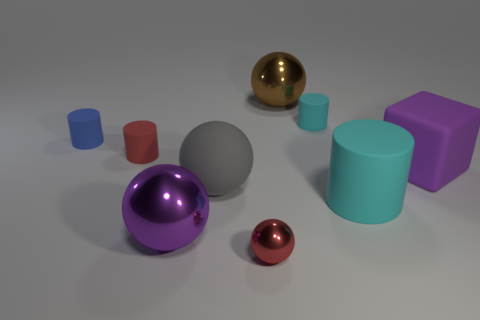Are any gray cubes visible? There are no gray cubes in view. The collection includes various geometric shapes such as spheres and cylinders, and while there is a gray sphere, cubes aren't present in this configuration. 